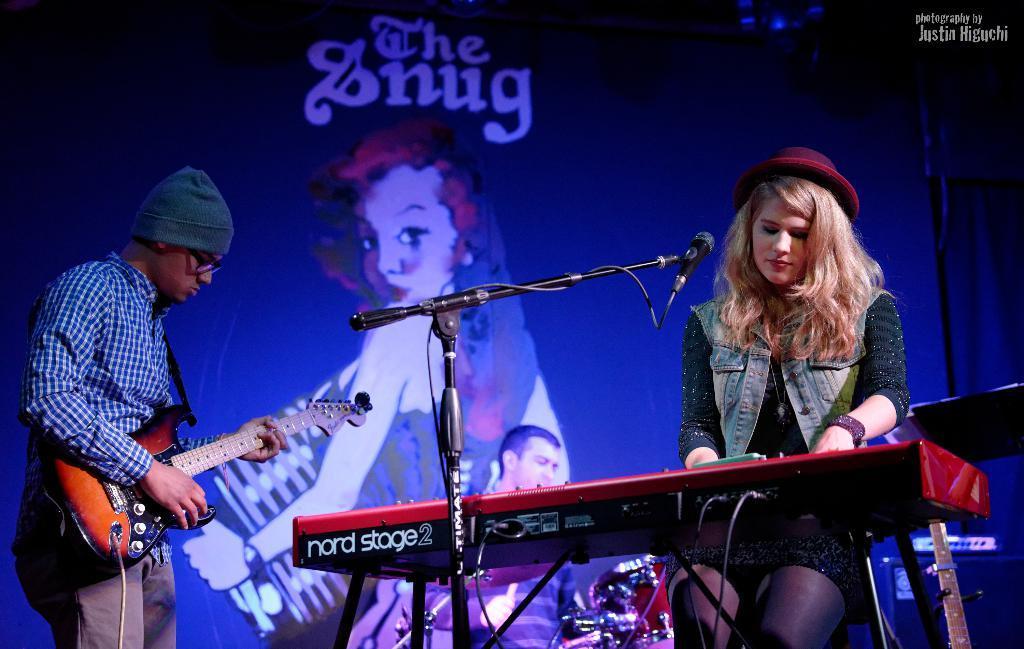In one or two sentences, can you explain what this image depicts? In this image a woman is sitting in the chair and she is playing piano. She is wearing jacket and cap. Before the piano there is a mike stand. Behind there is a person playing musical instrument. Left side there is a person standing and playing guitar. He is wearing spectacles and cap. Background there is a banner having a picture of a person and some text. 